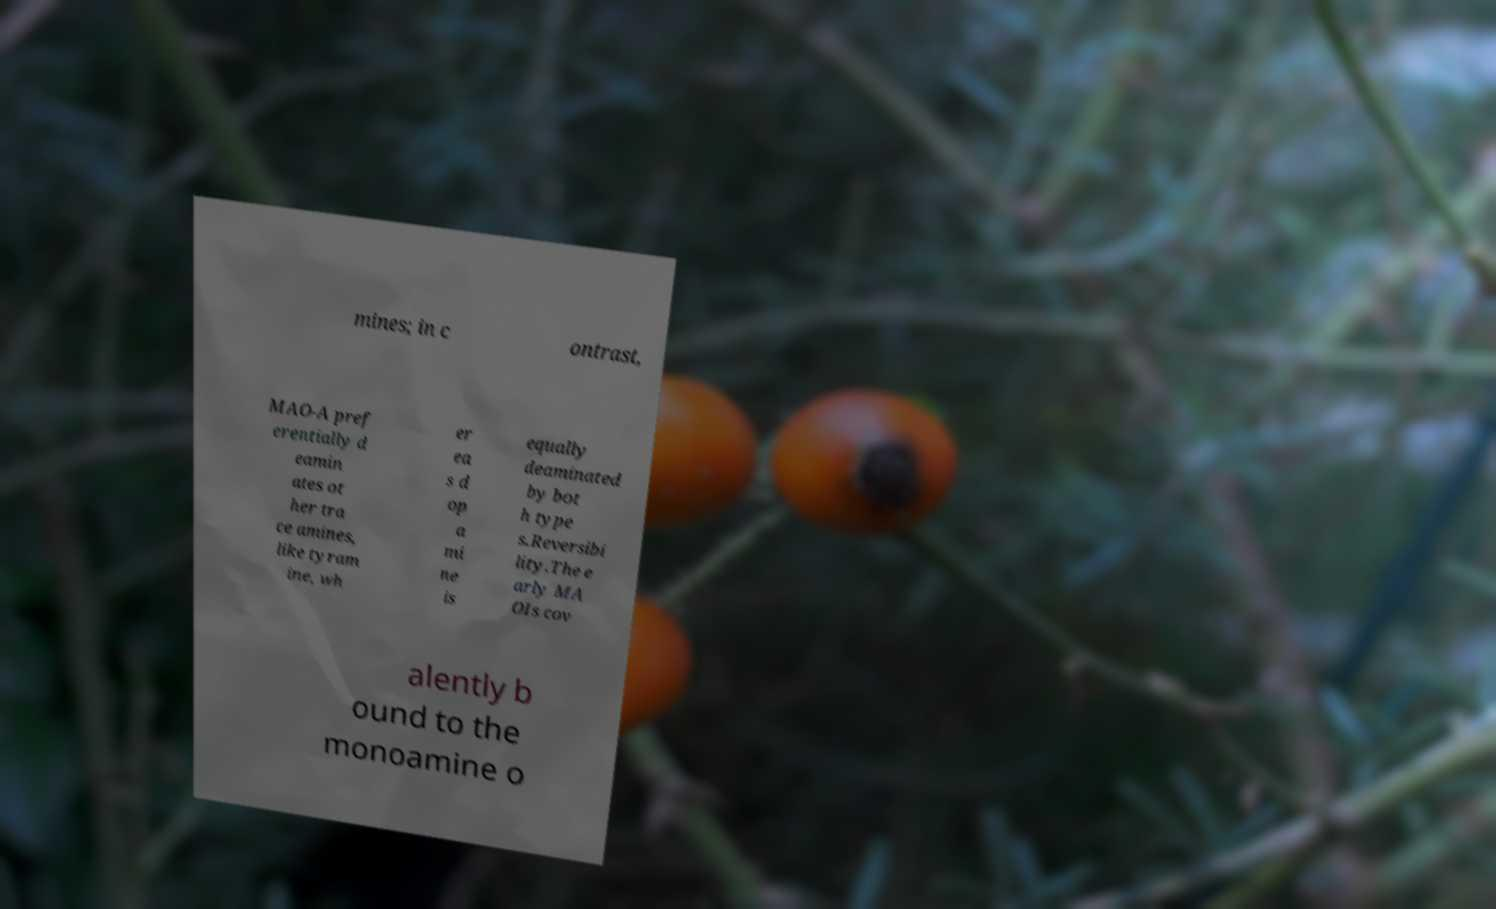Could you extract and type out the text from this image? mines; in c ontrast, MAO-A pref erentially d eamin ates ot her tra ce amines, like tyram ine, wh er ea s d op a mi ne is equally deaminated by bot h type s.Reversibi lity.The e arly MA OIs cov alently b ound to the monoamine o 